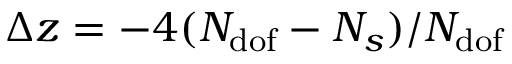Convert formula to latex. <formula><loc_0><loc_0><loc_500><loc_500>\Delta z = - 4 ( N _ { d o f } - N _ { s } ) / N _ { d o f }</formula> 